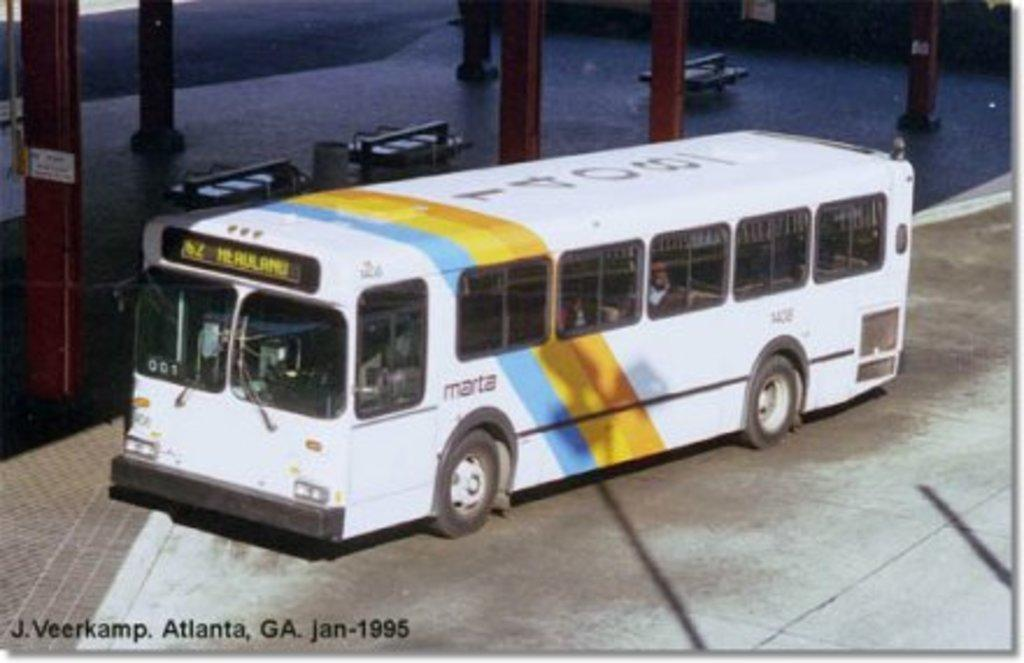<image>
Relay a brief, clear account of the picture shown. A Marta bus is parked by an empty covered waiting area. 